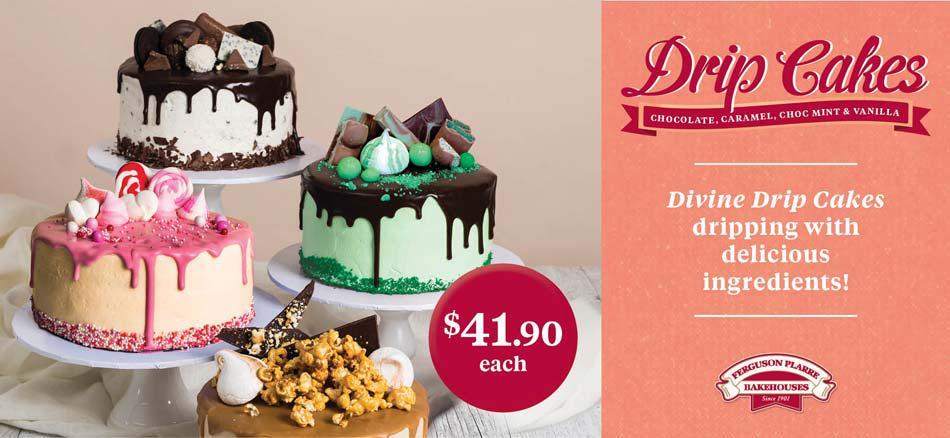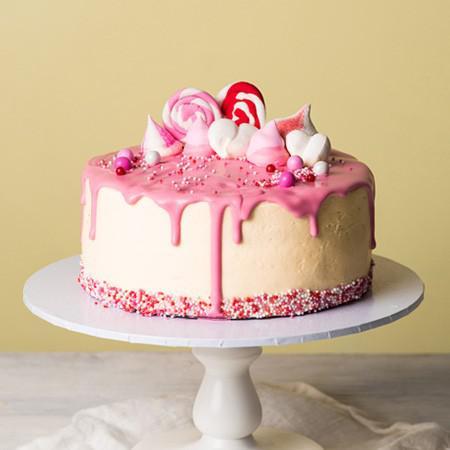The first image is the image on the left, the second image is the image on the right. Examine the images to the left and right. Is the description "Each image contains one cake with drip frosting effect and a ring of confetti sprinkles around the bottom, and the cake on the right has an inverted ice cream cone on its top." accurate? Answer yes or no. No. The first image is the image on the left, the second image is the image on the right. Considering the images on both sides, is "In at least one image there is an ice cream cone on top of a frosting drip cake." valid? Answer yes or no. No. 